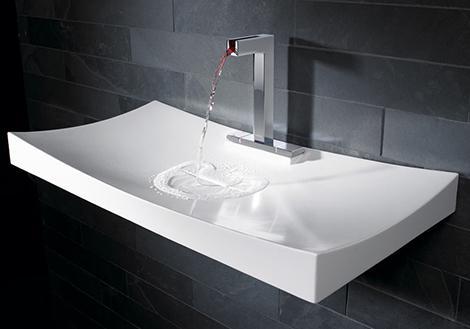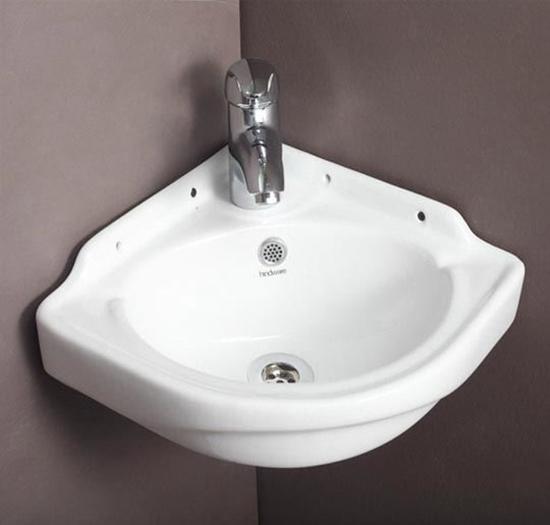The first image is the image on the left, the second image is the image on the right. Considering the images on both sides, is "At least one sink has no background, just plain white." valid? Answer yes or no. No. 